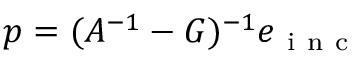Convert formula to latex. <formula><loc_0><loc_0><loc_500><loc_500>p = ( A ^ { - 1 } - G ) ^ { - 1 } e _ { i n c }</formula> 